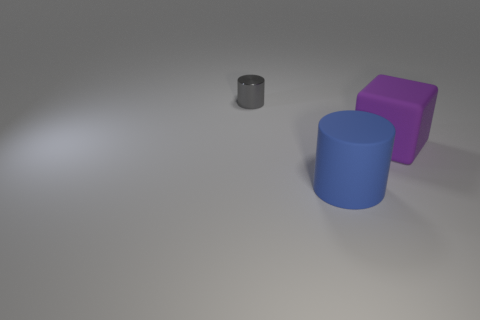Does the small gray metallic thing have the same shape as the blue object?
Your response must be concise. Yes. There is a matte thing that is right of the cylinder to the right of the cylinder left of the large matte cylinder; how big is it?
Make the answer very short. Large. What material is the tiny object that is the same shape as the large blue thing?
Make the answer very short. Metal. Are there any other things that are the same size as the shiny cylinder?
Provide a short and direct response. No. How big is the rubber object that is in front of the large thing that is to the right of the rubber cylinder?
Offer a very short reply. Large. The rubber cube has what color?
Keep it short and to the point. Purple. What number of rubber blocks are to the right of the cylinder that is behind the blue object?
Offer a very short reply. 1. Are there any metal cylinders in front of the cylinder in front of the gray metallic cylinder?
Your response must be concise. No. Are there any big blue cylinders on the left side of the small object?
Your answer should be compact. No. Does the object behind the large purple matte cube have the same shape as the big blue thing?
Keep it short and to the point. Yes. 